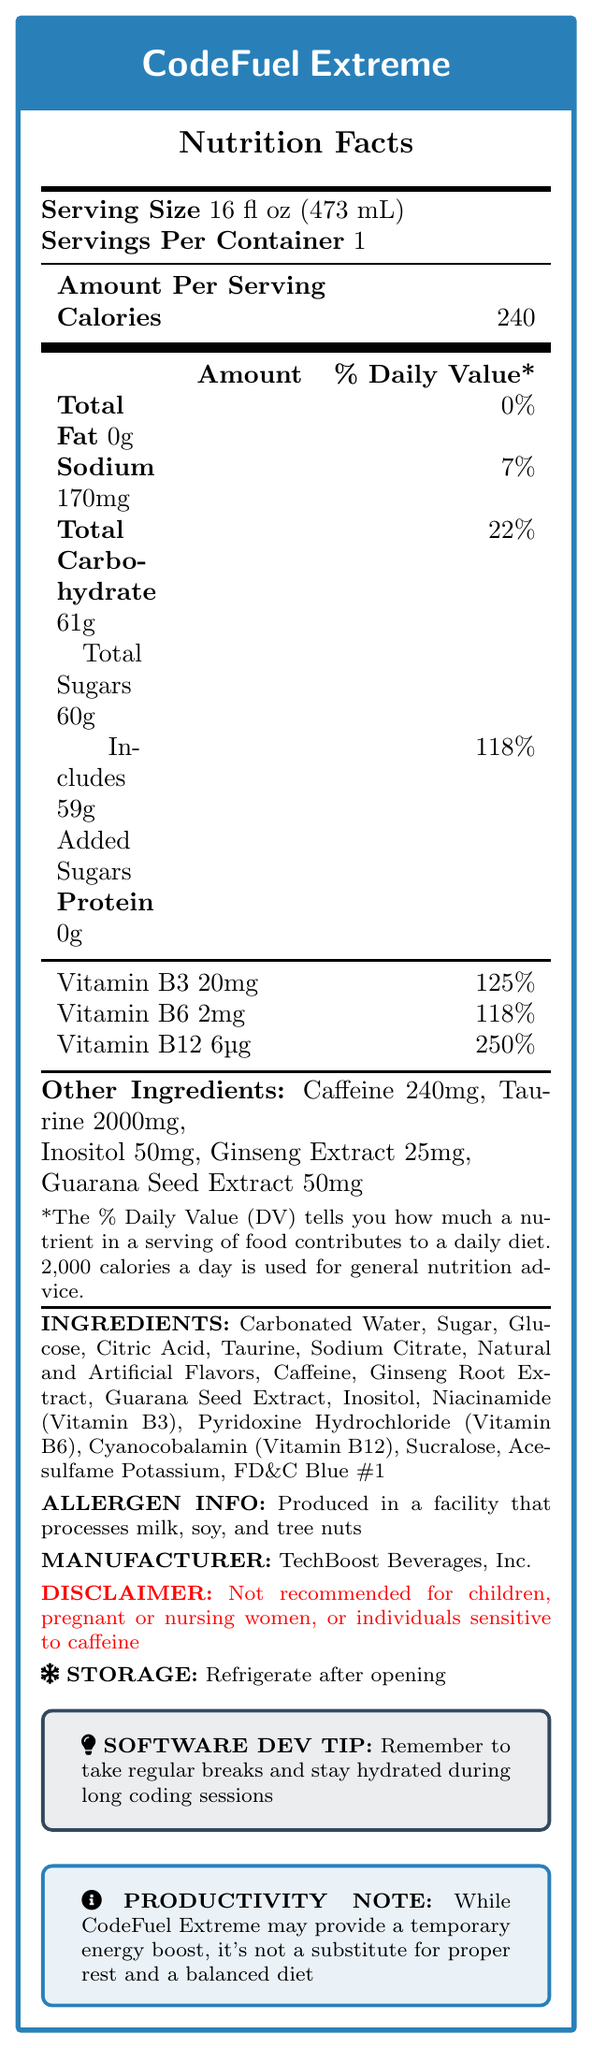what is the serving size of CodeFuel Extreme? The document states "Serving Size: 16 fl oz (473 mL)" at the top of the nutrition facts.
Answer: 16 fl oz (473 mL) how many calories are in one serving? The document shows "Calories: 240" under the "Amount Per Serving" section.
Answer: 240 what is the total carbohydrate content per serving? The "Total Carbohydrate" amount is listed as "61g" in the nutritional information table.
Answer: 61g what percentage of the daily value is the added sugars content? The added sugars content is listed as 118% of the daily value in the nutritional information table.
Answer: 118% what is the recommended storage method after opening? The document has a "STORAGE" section indicating, "Refrigerate after opening."
Answer: Refrigerate after opening how much caffeine is in one serving of CodeFuel Extreme? The document lists "Caffeine: 240mg" in the "Other Ingredients" section.
Answer: 240mg what does the disclaimer mention regarding who should avoid consuming this product? The disclaimer reads, "Not recommended for children, pregnant or nursing women, or individuals sensitive to caffeine."
Answer: Children, pregnant or nursing women, or individuals sensitive to caffeine which vitamin has the highest daily value percentage per serving? The document shows Vitamin B12 at 250% daily value, higher than Vitamin B3 (125%) and Vitamin B6 (118%).
Answer: Vitamin B12 what are the main active ingredients in CodeFuel Extreme? These ingredients are listed under "Other Ingredients" with their respective amounts.
Answer: Caffeine, Taurine, Inositol, Ginseng Extract, Guarana Seed Extract what is the total fat content per serving? The "Total Fat" content is listed as "0g" in the nutritional information table.
Answer: 0g which company manufactures CodeFuel Extreme?
A. TechBoost Beverages, Inc.
B. EnergyMasters Co.
C. CodeDrinks LLC. The document states, "MANUFACTURER: TechBoost Beverages, Inc."
Answer: A what is the main intended use of CodeFuel Extreme according to the productivity note?
I. Temporary energy boost
II. Substitute for proper rest
III. Substitute for a balanced diet The "PRODUCTIVITY NOTE" specifies that CodeFuel Extreme may provide a temporary energy boost but is not a substitute for proper rest and a balanced diet.
Answer: I is CodeFuel Extreme suitable for individuals with nut allergies? The document states, "Produced in a facility that processes milk, soy, and tree nuts," indicating potential allergen contamination.
Answer: No summarize the important details of the CodeFuel Extreme nutrition label. The main points include the serving size, nutritional content, key active ingredients, storage recommendation, unsuitable groups, and manufacturer details.
Answer: CodeFuel Extreme is an energy drink with a serving size of 16 fl oz (473 mL). It contains 240 calories per serving, with significant amounts of caffeine (240mg) and taurine (2000mg). The drink is high in sugars (60g), including 59g of added sugars (118% daily value). Key vitamins include B3, B6, and B12. The product should be refrigerated after opening and is not recommended for children, pregnant or nursing women, or individuals sensitive to caffeine. It is manufactured by TechBoost Beverages, Inc. how many grams of protein are in one serving? The document lists the Protein amount as "0g" in the nutritional information table.
Answer: 0g what is the primary artificial sweetener used in CodeFuel Extreme? The "INGREDIENTS" section lists Sucralose as one of the components.
Answer: Sucralose how much Inositol does each serving contain? The "Other Ingredients" section indicates that each serving contains 50mg of Inositol.
Answer: 50mg where is the company that manufactures CodeFuel Extreme located? The document does not provide any information on the location of TechBoost Beverages, Inc.
Answer: Cannot be determined 